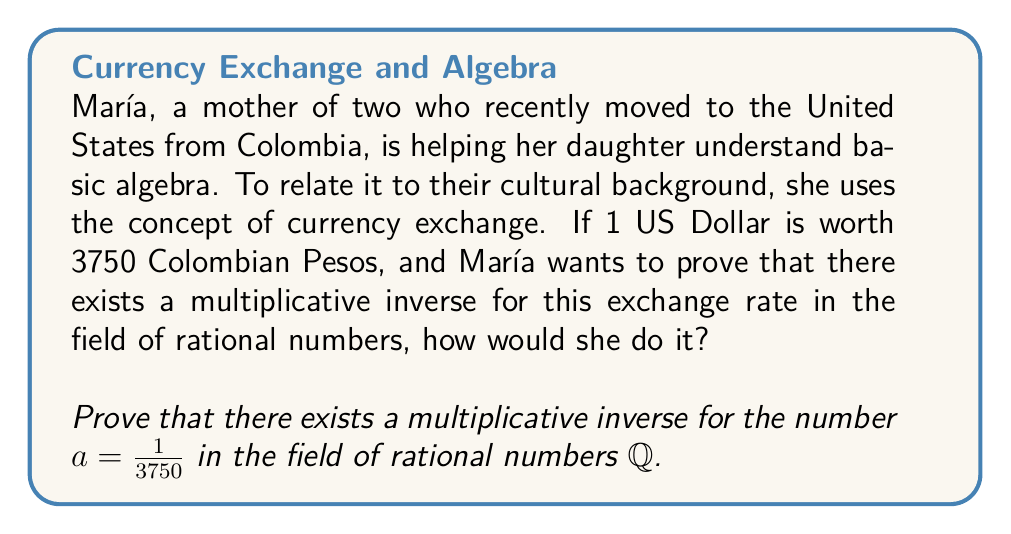Could you help me with this problem? To prove the existence of a multiplicative inverse for $a = \frac{1}{3750}$ in $\mathbb{Q}$, we need to find a rational number $b$ such that $ab = 1$. Let's proceed step by step:

1) In a field, every non-zero element has a multiplicative inverse. Since $a = \frac{1}{3750} \neq 0$, it should have an inverse in $\mathbb{Q}$.

2) To find the inverse, we can set up the equation:

   $a \cdot b = 1$

3) Substituting $a = \frac{1}{3750}$:

   $\frac{1}{3750} \cdot b = 1$

4) To solve for $b$, we multiply both sides by 3750:

   $3750 \cdot \frac{1}{3750} \cdot b = 3750 \cdot 1$

5) Simplifying:

   $b = 3750$

6) We can verify this result:

   $a \cdot b = \frac{1}{3750} \cdot 3750 = 1$

7) Since $b = 3750$ is a rational number (an integer is a rational number), we have found a multiplicative inverse for $a$ in $\mathbb{Q}$.

Therefore, we have proved that there exists a multiplicative inverse for $a = \frac{1}{3750}$ in the field of rational numbers $\mathbb{Q}$, and this inverse is $b = 3750$.
Answer: The multiplicative inverse of $\frac{1}{3750}$ in $\mathbb{Q}$ is 3750. 